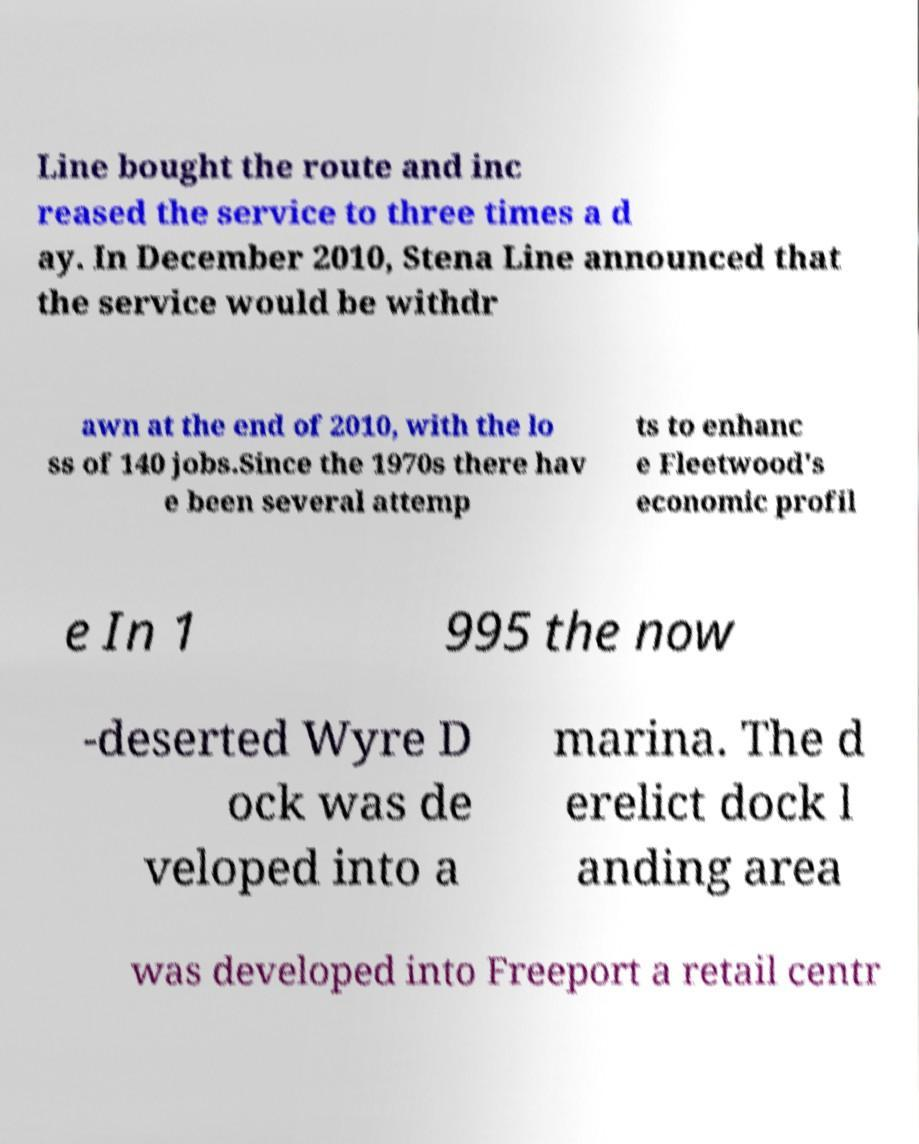For documentation purposes, I need the text within this image transcribed. Could you provide that? Line bought the route and inc reased the service to three times a d ay. In December 2010, Stena Line announced that the service would be withdr awn at the end of 2010, with the lo ss of 140 jobs.Since the 1970s there hav e been several attemp ts to enhanc e Fleetwood's economic profil e In 1 995 the now -deserted Wyre D ock was de veloped into a marina. The d erelict dock l anding area was developed into Freeport a retail centr 